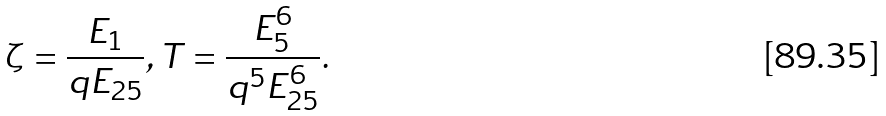Convert formula to latex. <formula><loc_0><loc_0><loc_500><loc_500>\zeta = \frac { E _ { 1 } } { q E _ { 2 5 } } , T = \frac { E _ { 5 } ^ { 6 } } { q ^ { 5 } E _ { 2 5 } ^ { 6 } } .</formula> 